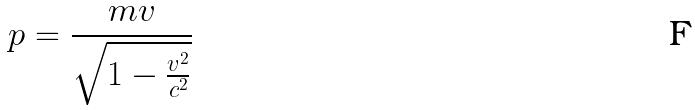Convert formula to latex. <formula><loc_0><loc_0><loc_500><loc_500>p = \frac { m v } { \sqrt { 1 - \frac { v ^ { 2 } } { c ^ { 2 } } } }</formula> 